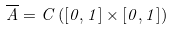<formula> <loc_0><loc_0><loc_500><loc_500>\overline { A } = C \left ( \left [ 0 , 1 \right ] \times \left [ 0 , 1 \right ] \right )</formula> 